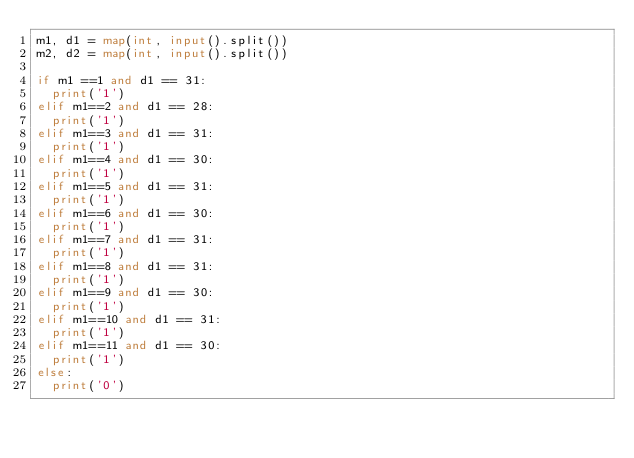<code> <loc_0><loc_0><loc_500><loc_500><_Python_>m1, d1 = map(int, input().split())
m2, d2 = map(int, input().split())

if m1 ==1 and d1 == 31:
  print('1')
elif m1==2 and d1 == 28:
  print('1')
elif m1==3 and d1 == 31:
  print('1')
elif m1==4 and d1 == 30:
  print('1')
elif m1==5 and d1 == 31:
  print('1')
elif m1==6 and d1 == 30:
  print('1')
elif m1==7 and d1 == 31:
  print('1')
elif m1==8 and d1 == 31:
  print('1')
elif m1==9 and d1 == 30:
  print('1')
elif m1==10 and d1 == 31:
  print('1')
elif m1==11 and d1 == 30:
  print('1')
else:
  print('0')</code> 